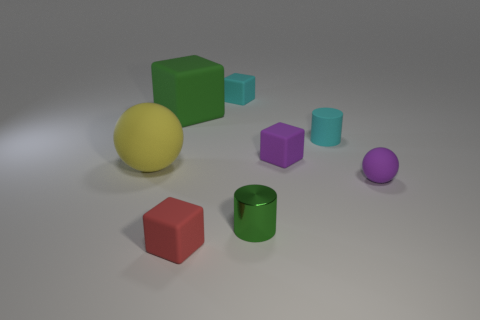What is the size of the green rubber cube that is to the left of the cyan matte object behind the tiny cylinder behind the yellow rubber sphere?
Your answer should be very brief. Large. There is a small matte block that is behind the cyan cylinder; how many metal things are to the left of it?
Give a very brief answer. 0. What size is the object that is to the right of the red matte cube and left of the small metallic cylinder?
Ensure brevity in your answer.  Small. What number of metal things are either yellow objects or big blocks?
Give a very brief answer. 0. What is the material of the small green object?
Make the answer very short. Metal. There is a cyan object that is behind the rubber cube left of the small object that is in front of the small green cylinder; what is its material?
Offer a very short reply. Rubber. The purple matte object that is the same size as the purple matte cube is what shape?
Your response must be concise. Sphere. How many objects are either small red things or small objects that are in front of the big rubber block?
Keep it short and to the point. 5. Does the ball to the left of the red matte thing have the same material as the ball right of the big green cube?
Keep it short and to the point. Yes. What is the shape of the object that is the same color as the small ball?
Give a very brief answer. Cube. 